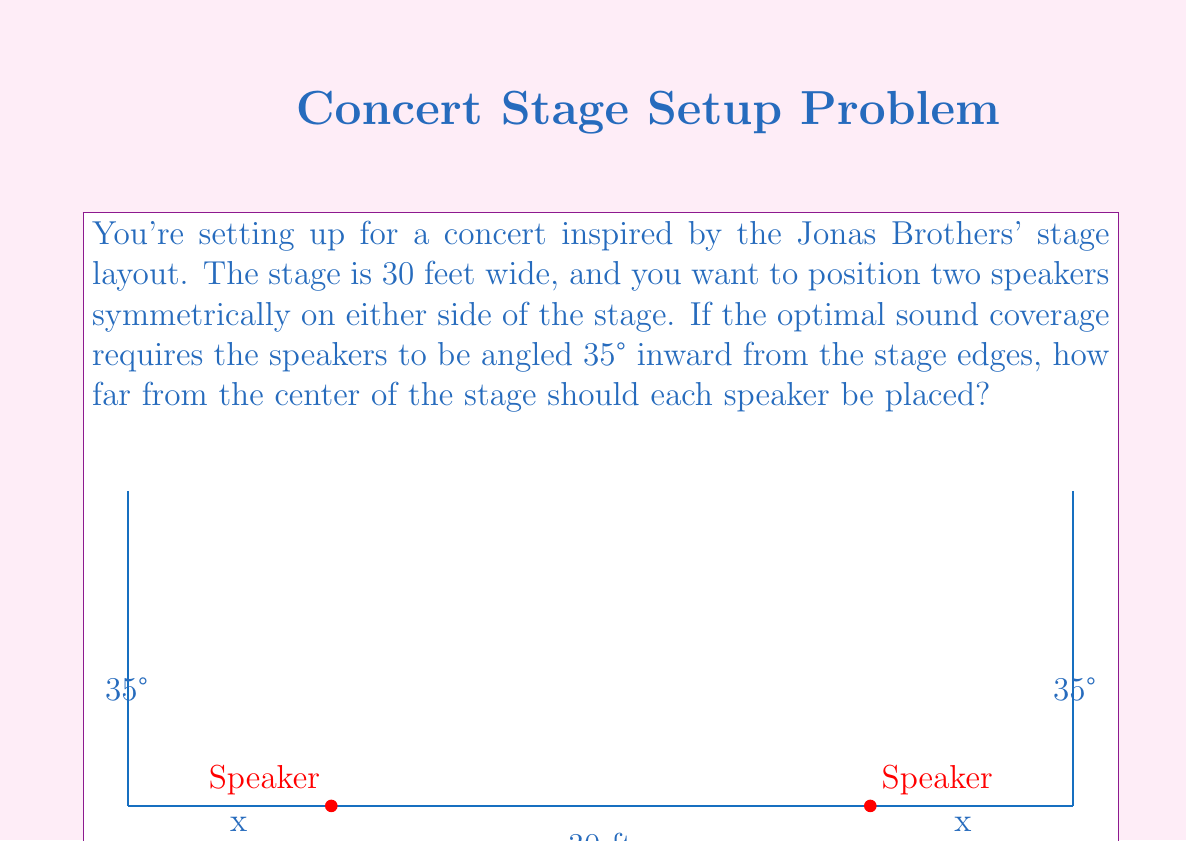Solve this math problem. Let's approach this step-by-step using trigonometry:

1) First, we need to recognize that this forms two right triangles, one on each side of the stage.

2) We're given that the stage is 30 feet wide, so each half of the stage is 15 feet.

3) The angle between the speaker line and the edge of the stage is 35°.

4) Let's focus on one side. We need to find the adjacent side of the right triangle formed.

5) We can use the tangent ratio:

   $\tan 35° = \frac{\text{opposite}}{\text{adjacent}} = \frac{15}{\text{x}}$

   Where x is the distance from the center to the speaker.

6) Rearranging this equation:

   $x = \frac{15}{\tan 35°}$

7) Now we can calculate:

   $x = \frac{15}{\tan 35°} \approx 21.443$ feet

8) This is the distance from the edge of the stage to the speaker. To get the distance from the center, we subtract this from half the stage width:

   $15 - 21.443 \approx -6.443$ feet

9) The negative sign just indicates it's to the left of center. The absolute value, 6.443 feet, is the distance from the center we're looking for.
Answer: $$6.443 \text{ feet}$$ 